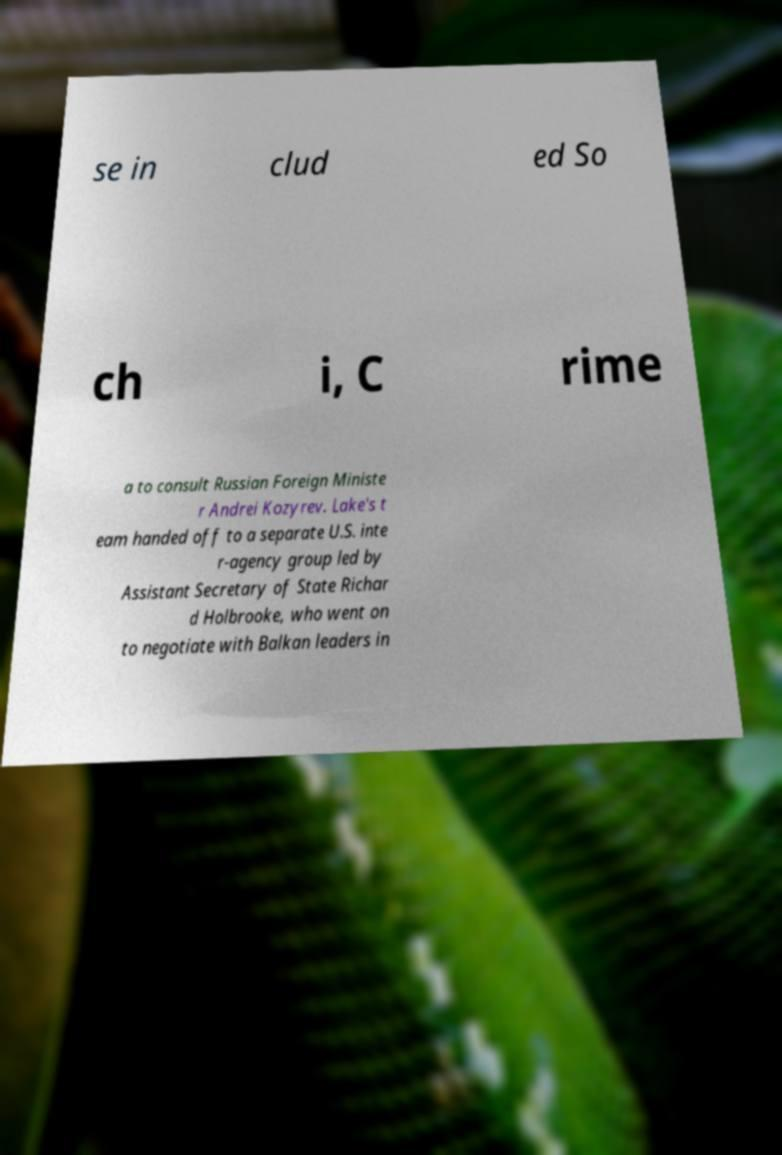Please identify and transcribe the text found in this image. se in clud ed So ch i, C rime a to consult Russian Foreign Ministe r Andrei Kozyrev. Lake's t eam handed off to a separate U.S. inte r-agency group led by Assistant Secretary of State Richar d Holbrooke, who went on to negotiate with Balkan leaders in 